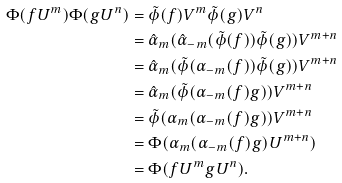<formula> <loc_0><loc_0><loc_500><loc_500>\Phi ( f U ^ { m } ) \Phi ( g U ^ { n } ) & = \tilde { \phi } ( f ) V ^ { m } \tilde { \phi } ( g ) V ^ { n } \\ & = \hat { \alpha } _ { m } ( \hat { \alpha } _ { - m } ( \tilde { \phi } ( f ) ) \tilde { \phi } ( g ) ) V ^ { m + n } \\ & = \hat { \alpha } _ { m } ( \tilde { \phi } ( \alpha _ { - m } ( f ) ) \tilde { \phi } ( g ) ) V ^ { m + n } \\ & = \hat { \alpha } _ { m } ( \tilde { \phi } ( \alpha _ { - m } ( f ) g ) ) V ^ { m + n } \\ & = \tilde { \phi } ( \alpha _ { m } ( \alpha _ { - m } ( f ) g ) ) V ^ { m + n } \\ & = \Phi ( \alpha _ { m } ( \alpha _ { - m } ( f ) g ) U ^ { m + n } ) \\ & = \Phi ( f U ^ { m } g U ^ { n } ) .</formula> 